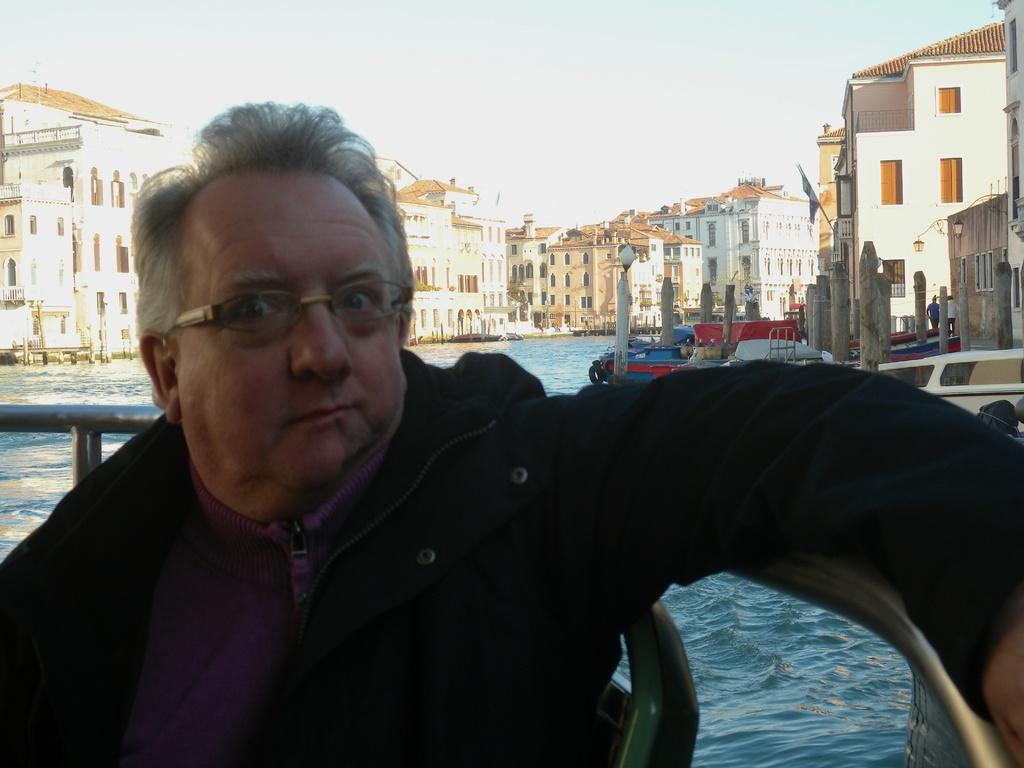Who is present in the image? There is a woman in the image. What is visible in the image besides the woman? Water, buildings, and the sky are visible in the image. Can you describe the background of the image? The sky is visible in the background of the image. What arithmetic problem is the woman solving in the image? There is no indication in the image that the woman is solving an arithmetic problem. 